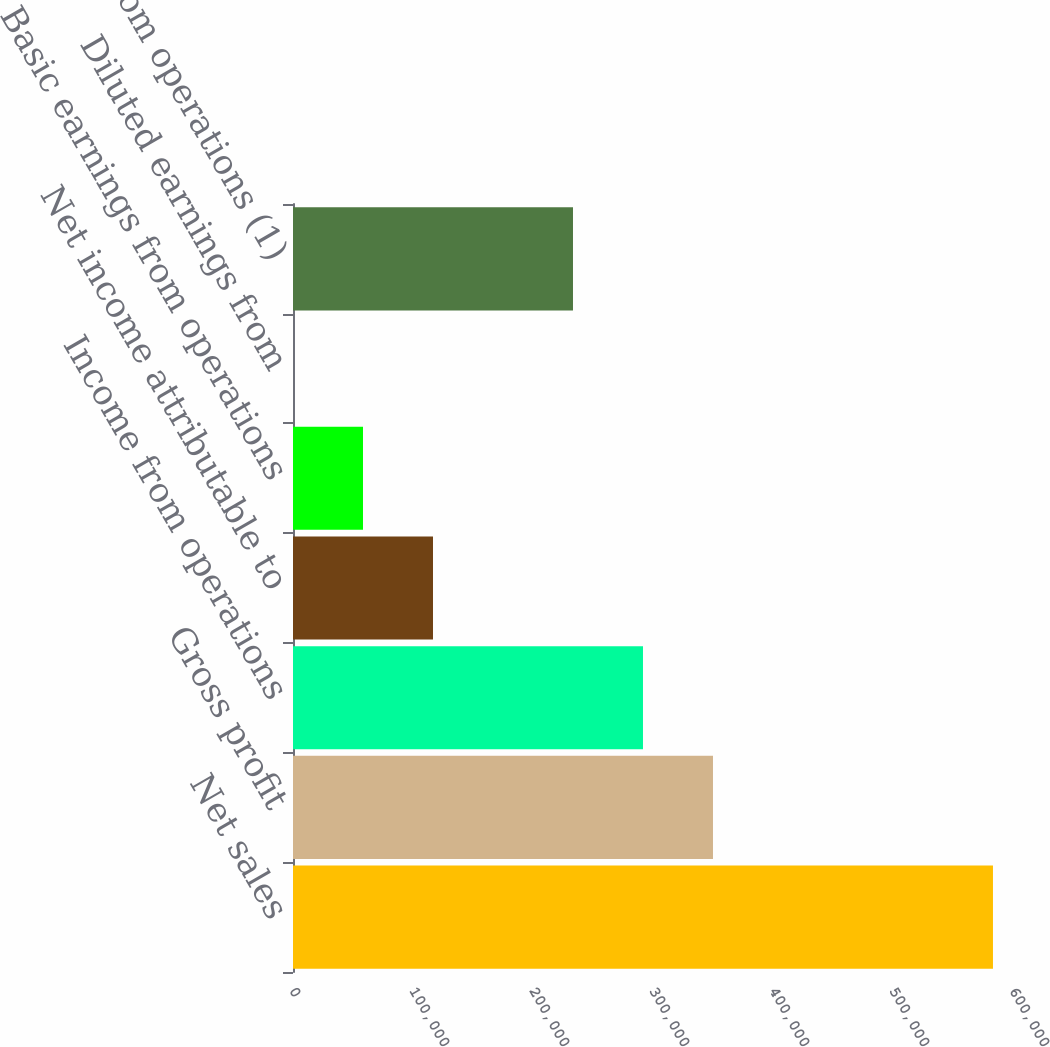Convert chart to OTSL. <chart><loc_0><loc_0><loc_500><loc_500><bar_chart><fcel>Net sales<fcel>Gross profit<fcel>Income from operations<fcel>Net income attributable to<fcel>Basic earnings from operations<fcel>Diluted earnings from<fcel>Income from operations (1)<nl><fcel>583309<fcel>349986<fcel>291655<fcel>116663<fcel>58332<fcel>1.22<fcel>233324<nl></chart> 